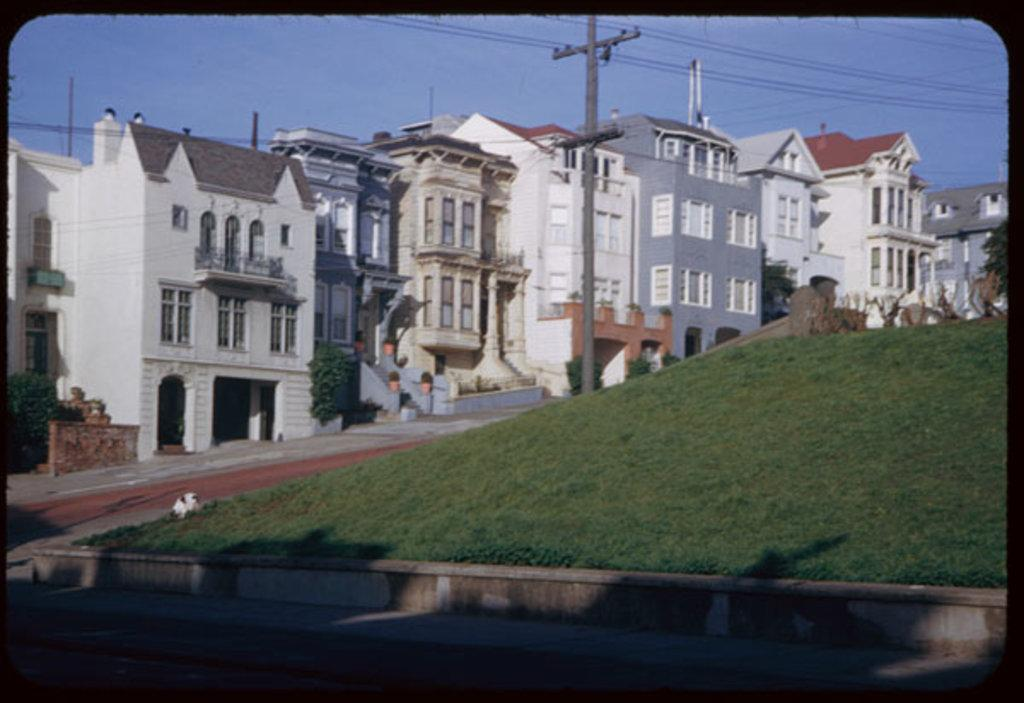What type of structures can be seen in the image? There are buildings in the image. What is the vertical object in the image? There is a pole in the image. What is visible at the top of the image? The sky is visible at the top of the image. What type of infrastructure is present in the image? Wires are present in the image. What is at the bottom of the image? There is a road and grass visible at the bottom of the image. Can you tell me how many cans of paint are on the bed in the image? There is no bed or cans of paint present in the image. What type of building is shown in the image? The provided facts do not specify the type of building; only that there are buildings in the image. 